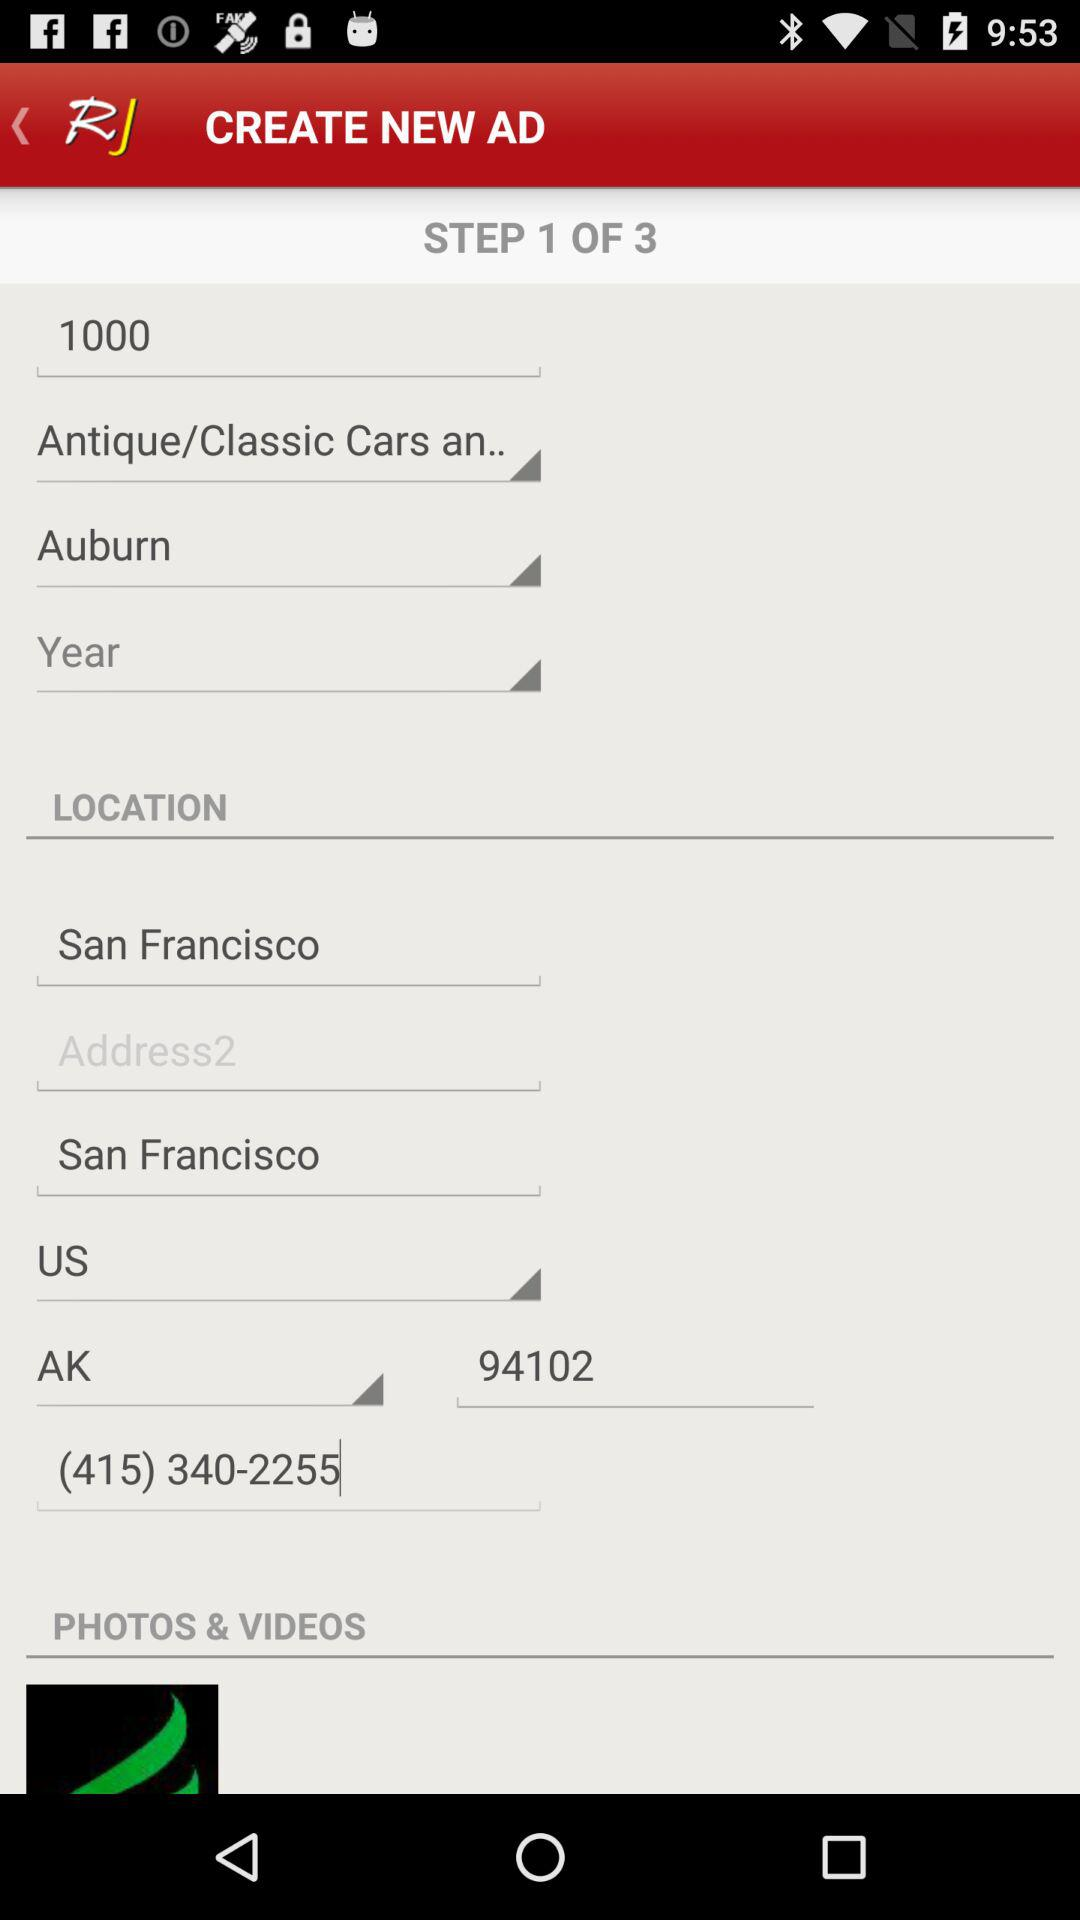What is the location? The location is San Francisco, US. 